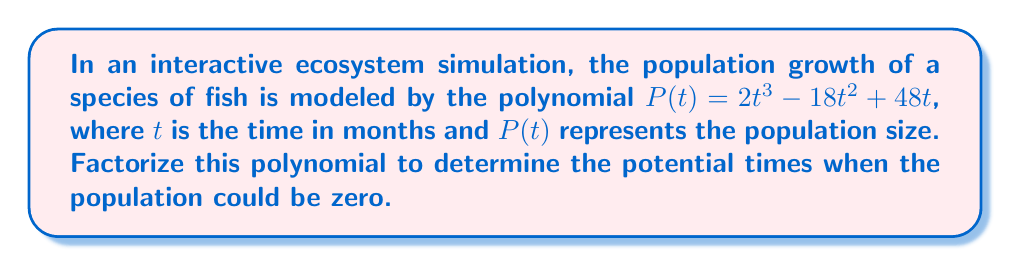Solve this math problem. Let's approach this step-by-step:

1) The polynomial is $P(t) = 2t^3 - 18t^2 + 48t$

2) We can factor out the greatest common factor (GCF):
   $P(t) = 2t(t^2 - 9t + 24)$

3) Now we need to factorize the quadratic expression inside the parentheses:
   $t^2 - 9t + 24$

4) We're looking for two numbers that multiply to give 24 and add to give -9.
   These numbers are -3 and -6.

5) So we can rewrite the quadratic as:
   $(t - 3)(t - 6)$

6) Putting it all together:
   $P(t) = 2t(t - 3)(t - 6)$

7) Therefore, the population could be zero at three times:
   - When $t = 0$ (initial time)
   - When $t = 3$ (after 3 months)
   - When $t = 6$ (after 6 months)

This factorization allows students to visualize the potential zero points of the population growth model in the ecosystem simulation.
Answer: $P(t) = 2t(t - 3)(t - 6)$ 